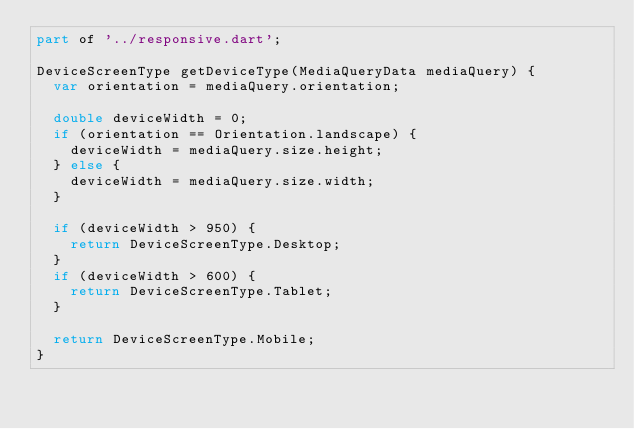<code> <loc_0><loc_0><loc_500><loc_500><_Dart_>part of '../responsive.dart';

DeviceScreenType getDeviceType(MediaQueryData mediaQuery) {
  var orientation = mediaQuery.orientation;

  double deviceWidth = 0;
  if (orientation == Orientation.landscape) {
    deviceWidth = mediaQuery.size.height;
  } else {
    deviceWidth = mediaQuery.size.width;
  }

  if (deviceWidth > 950) {
    return DeviceScreenType.Desktop;
  }
  if (deviceWidth > 600) {
    return DeviceScreenType.Tablet;
  }

  return DeviceScreenType.Mobile;
}
</code> 